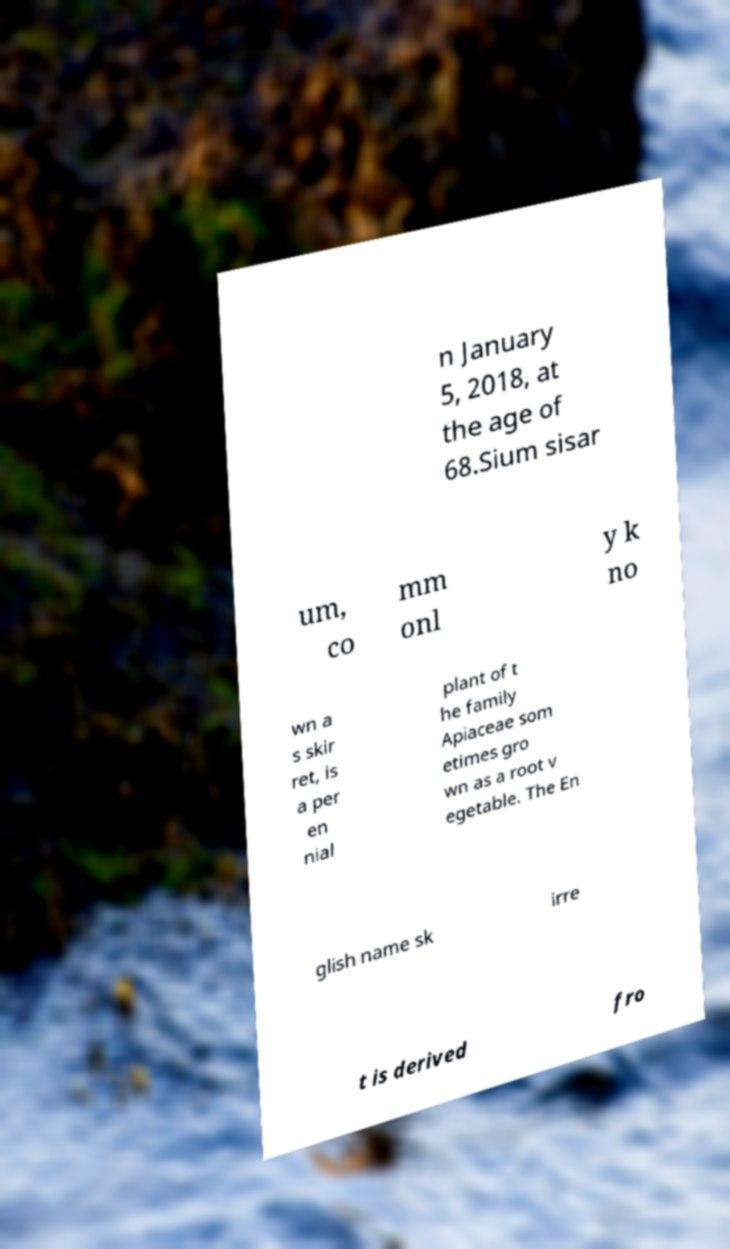Please identify and transcribe the text found in this image. n January 5, 2018, at the age of 68.Sium sisar um, co mm onl y k no wn a s skir ret, is a per en nial plant of t he family Apiaceae som etimes gro wn as a root v egetable. The En glish name sk irre t is derived fro 